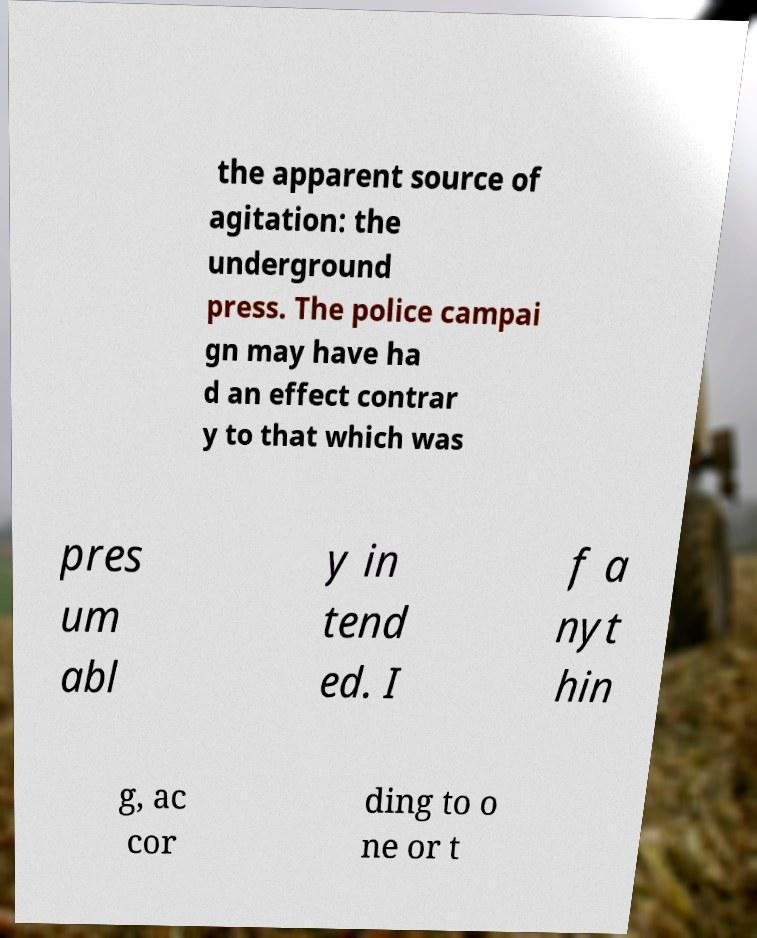Can you read and provide the text displayed in the image?This photo seems to have some interesting text. Can you extract and type it out for me? the apparent source of agitation: the underground press. The police campai gn may have ha d an effect contrar y to that which was pres um abl y in tend ed. I f a nyt hin g, ac cor ding to o ne or t 